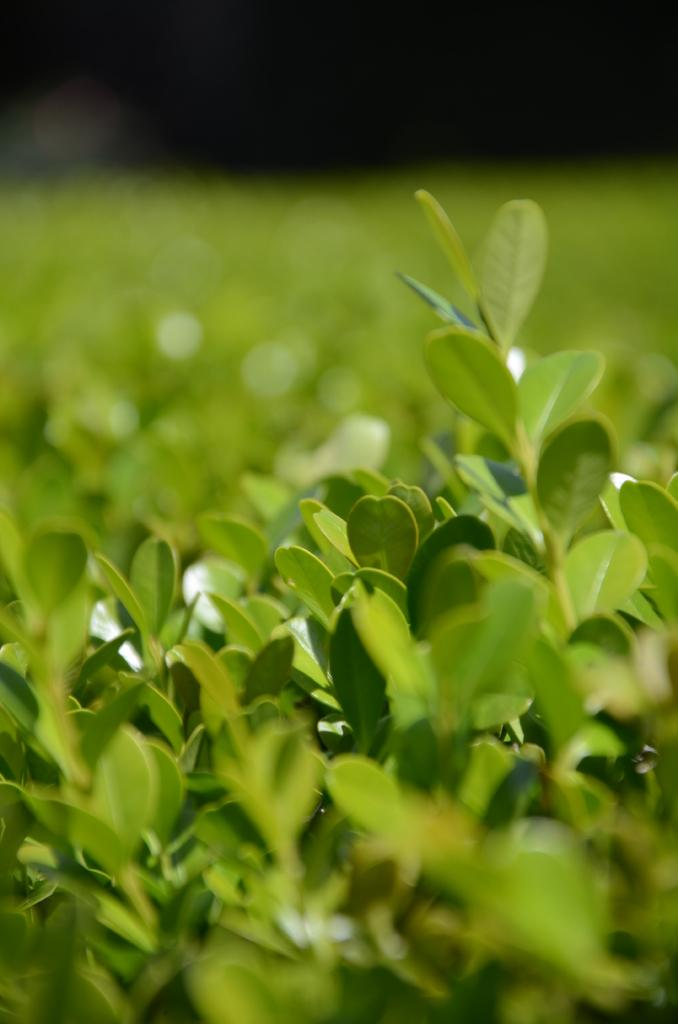What type of plants are in the image? There are herbs in the image. What type of needle is used to sew the herbs together in the image? There is no needle or sewing activity present in the image; it features herbs. How many times do the herbs turn in the image? The herbs do not turn in the image; they are stationary. 